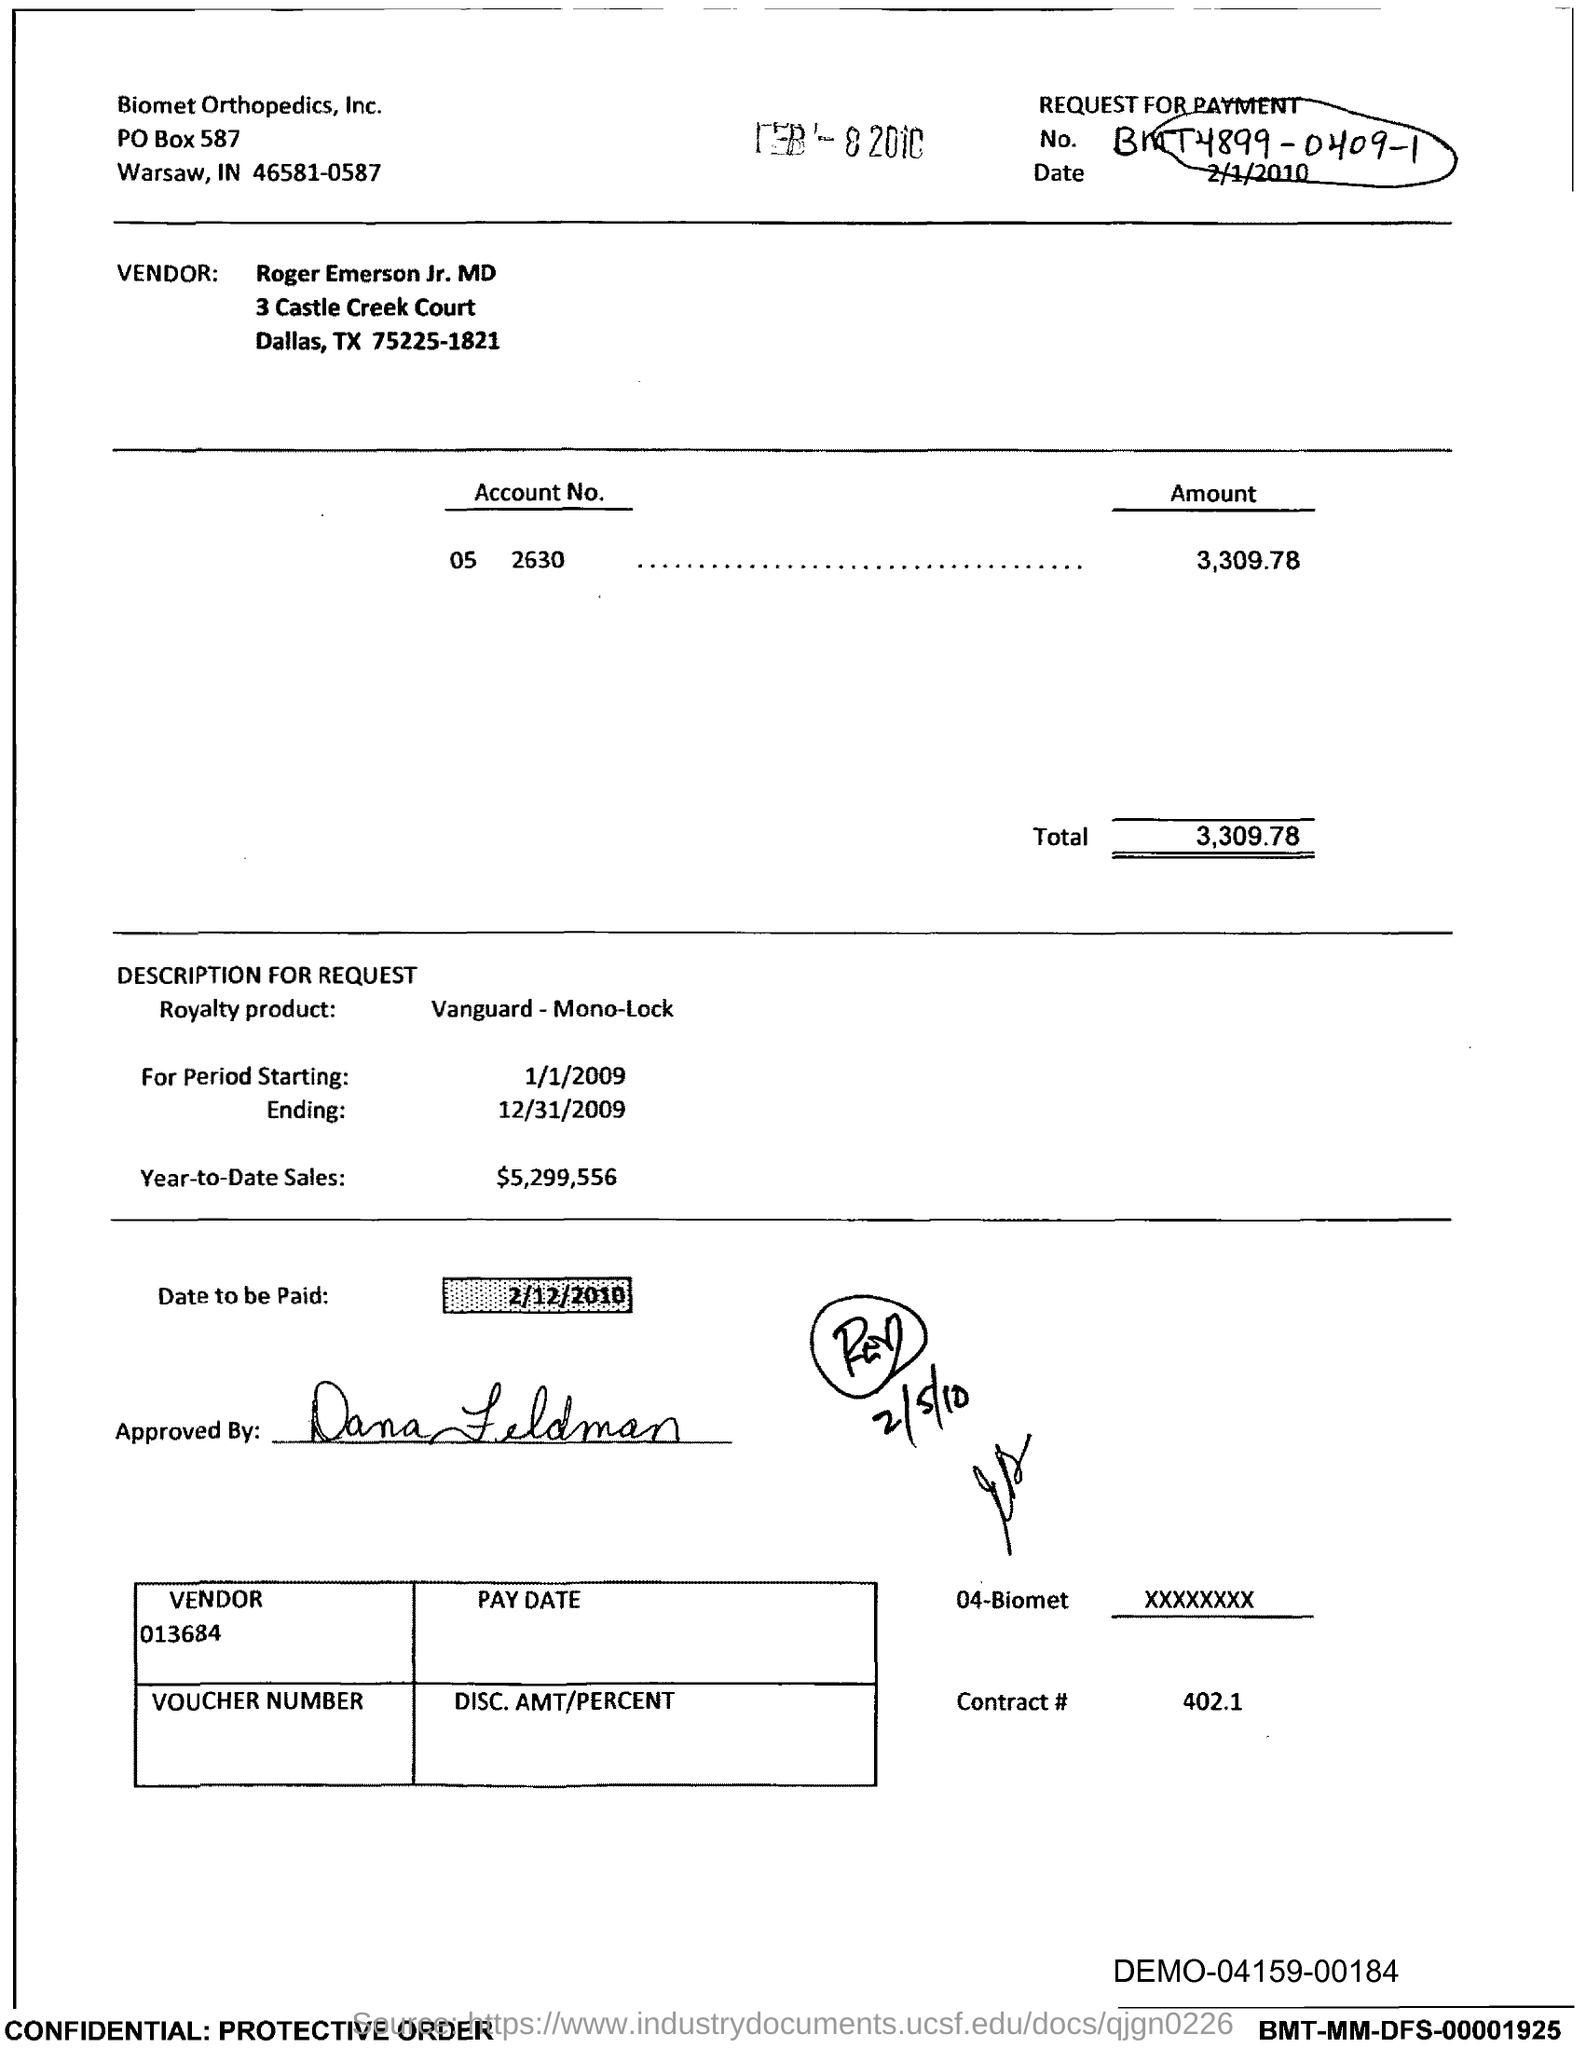What is the Contract # Number?
Provide a short and direct response. 402.1. What is the date to be paid?
Ensure brevity in your answer.  2/12/2010. What is the Year-to-Date-Sales?
Your answer should be very brief. $5,299,556. 